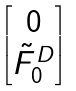Convert formula to latex. <formula><loc_0><loc_0><loc_500><loc_500>\begin{bmatrix} 0 \\ \tilde { F } _ { 0 } ^ { D } \end{bmatrix}</formula> 